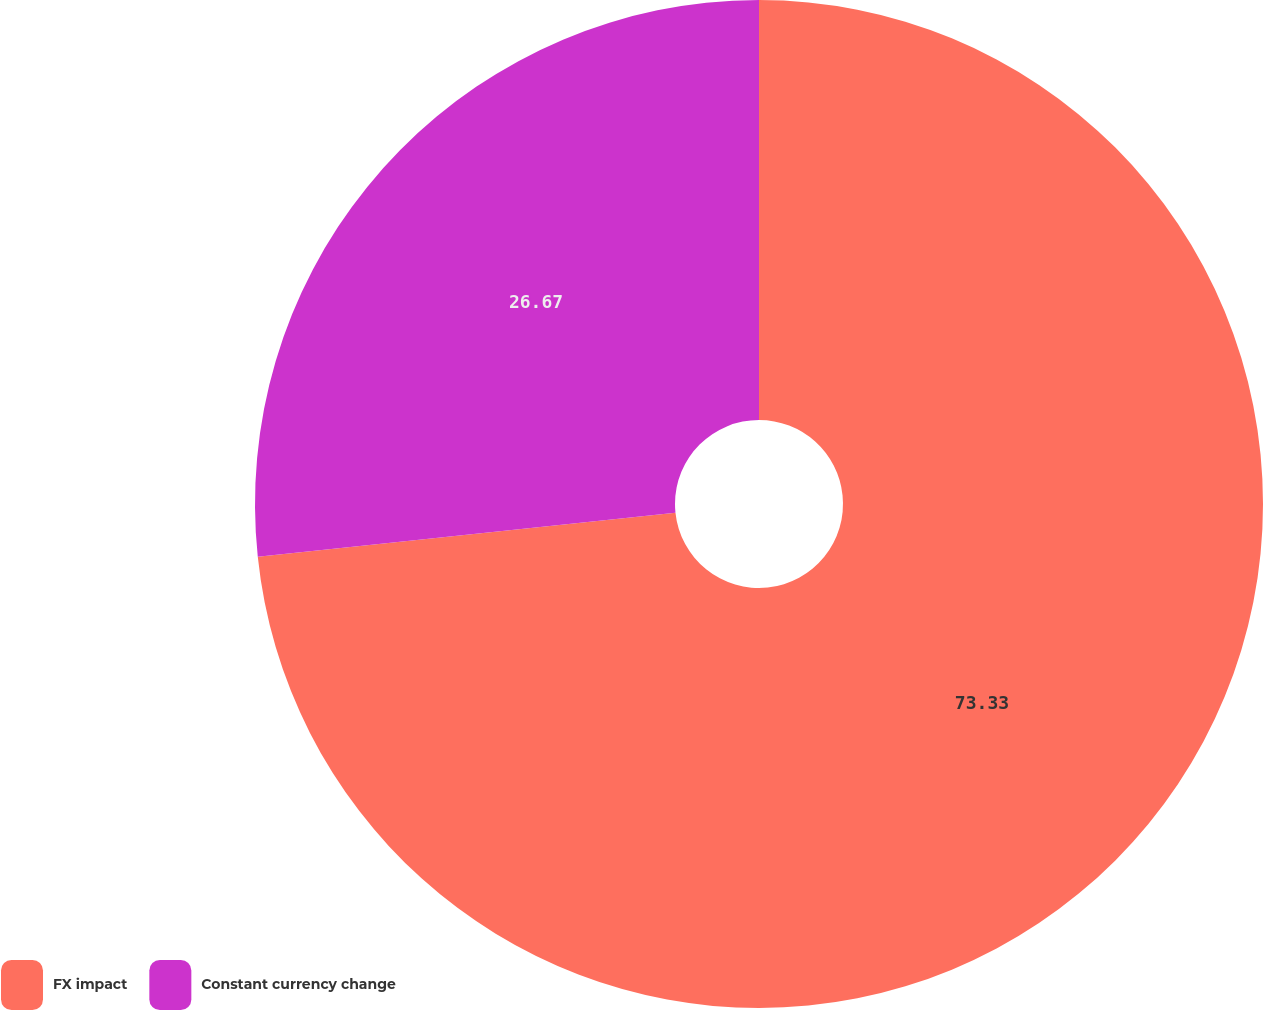<chart> <loc_0><loc_0><loc_500><loc_500><pie_chart><fcel>FX impact<fcel>Constant currency change<nl><fcel>73.33%<fcel>26.67%<nl></chart> 